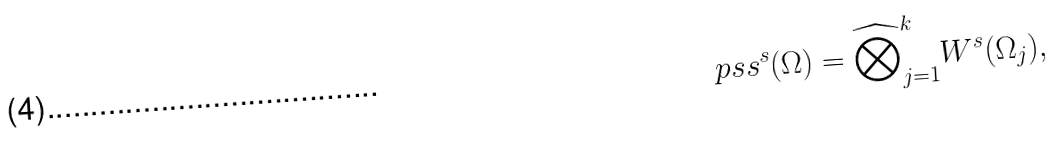Convert formula to latex. <formula><loc_0><loc_0><loc_500><loc_500>\ p s s ^ { s } ( \Omega ) = { \widehat { \bigotimes } } _ { j = 1 } ^ { k } W ^ { s } ( \Omega _ { j } ) ,</formula> 